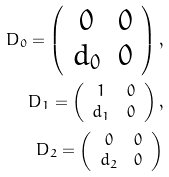<formula> <loc_0><loc_0><loc_500><loc_500>D _ { 0 } = \left ( \begin{array} { c c } 0 & 0 \\ d _ { 0 } & 0 \\ \end{array} \right ) , \\ D _ { 1 } = \left ( \begin{array} { c c } 1 & 0 \\ d _ { 1 } & 0 \\ \end{array} \right ) , \\ D _ { 2 } = \left ( \begin{array} { c c } 0 & 0 \\ d _ { 2 } & 0 \\ \end{array} \right )</formula> 